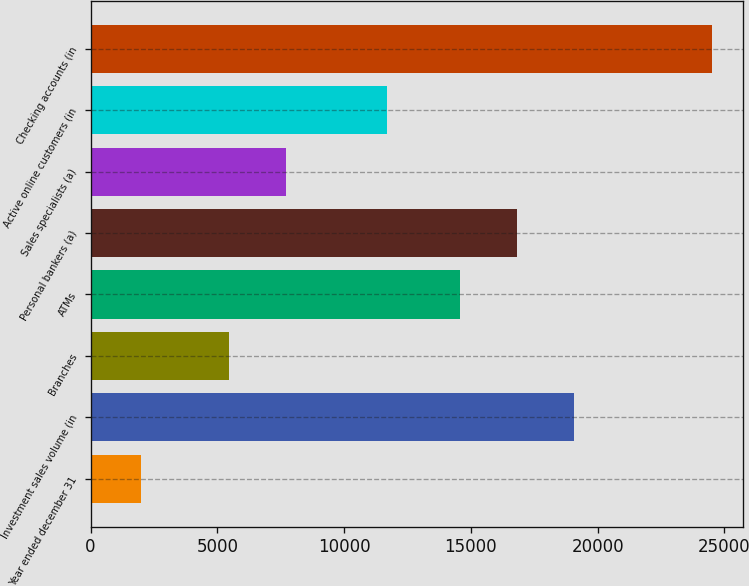Convert chart to OTSL. <chart><loc_0><loc_0><loc_500><loc_500><bar_chart><fcel>Year ended december 31<fcel>Investment sales volume (in<fcel>Branches<fcel>ATMs<fcel>Personal bankers (a)<fcel>Sales specialists (a)<fcel>Active online customers (in<fcel>Checking accounts (in<nl><fcel>2008<fcel>19066.2<fcel>5474<fcel>14568<fcel>16817.1<fcel>7723.1<fcel>11710<fcel>24499<nl></chart> 